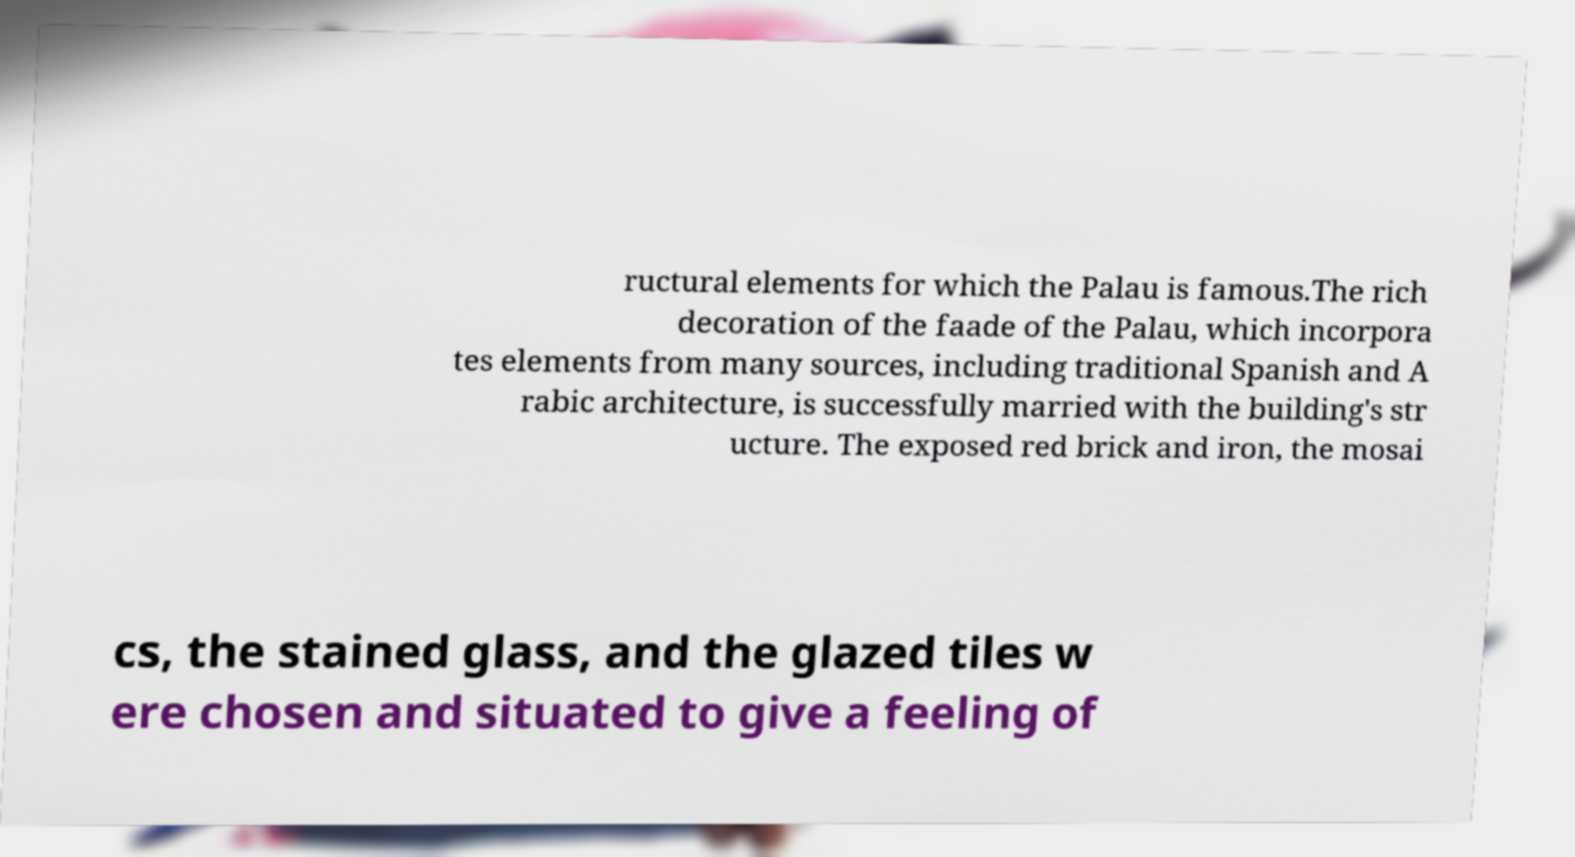For documentation purposes, I need the text within this image transcribed. Could you provide that? ructural elements for which the Palau is famous.The rich decoration of the faade of the Palau, which incorpora tes elements from many sources, including traditional Spanish and A rabic architecture, is successfully married with the building's str ucture. The exposed red brick and iron, the mosai cs, the stained glass, and the glazed tiles w ere chosen and situated to give a feeling of 